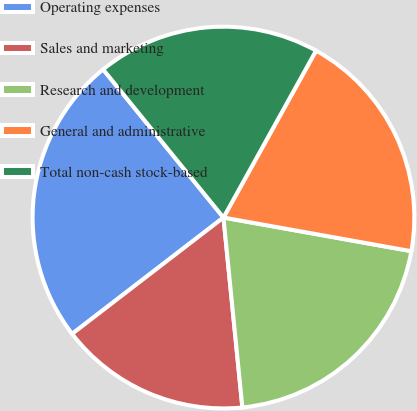Convert chart. <chart><loc_0><loc_0><loc_500><loc_500><pie_chart><fcel>Operating expenses<fcel>Sales and marketing<fcel>Research and development<fcel>General and administrative<fcel>Total non-cash stock-based<nl><fcel>24.57%<fcel>16.15%<fcel>20.6%<fcel>19.76%<fcel>18.92%<nl></chart> 